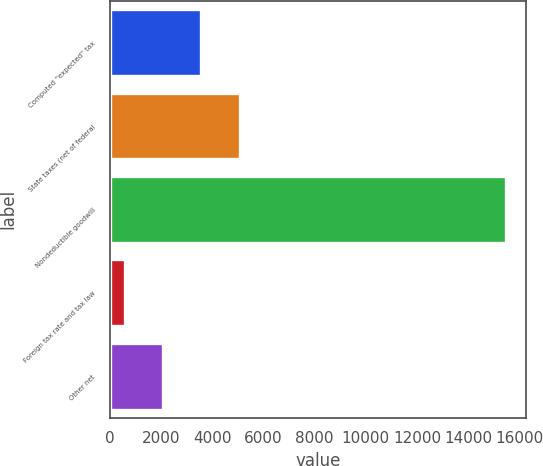<chart> <loc_0><loc_0><loc_500><loc_500><bar_chart><fcel>Computed ''expected'' tax<fcel>State taxes (net of federal<fcel>Nondeductible goodwill<fcel>Foreign tax rate and tax law<fcel>Other net<nl><fcel>3574.6<fcel>5062.9<fcel>15481<fcel>598<fcel>2086.3<nl></chart> 